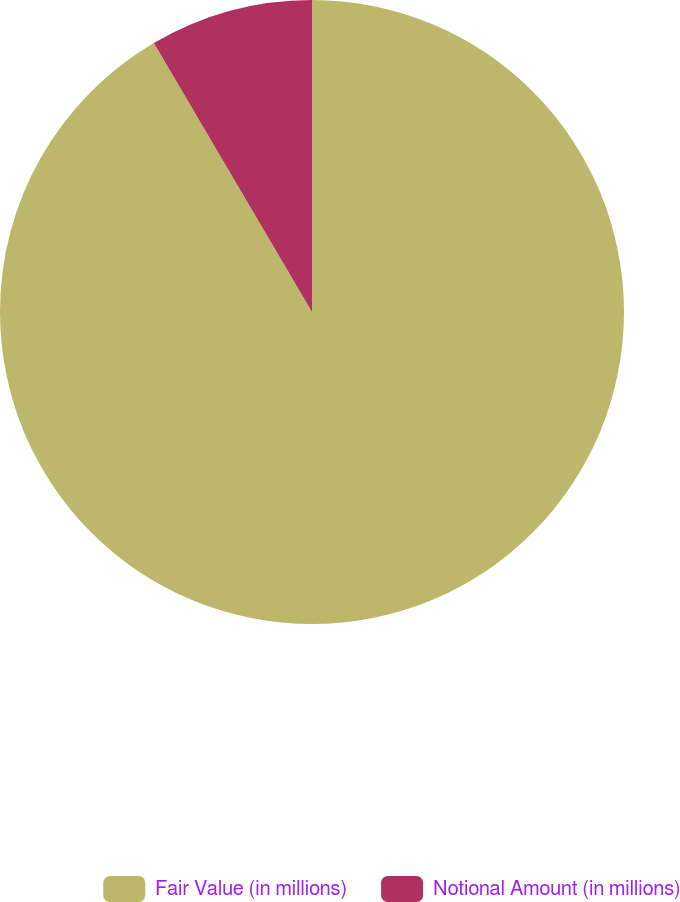<chart> <loc_0><loc_0><loc_500><loc_500><pie_chart><fcel>Fair Value (in millions)<fcel>Notional Amount (in millions)<nl><fcel>91.54%<fcel>8.46%<nl></chart> 